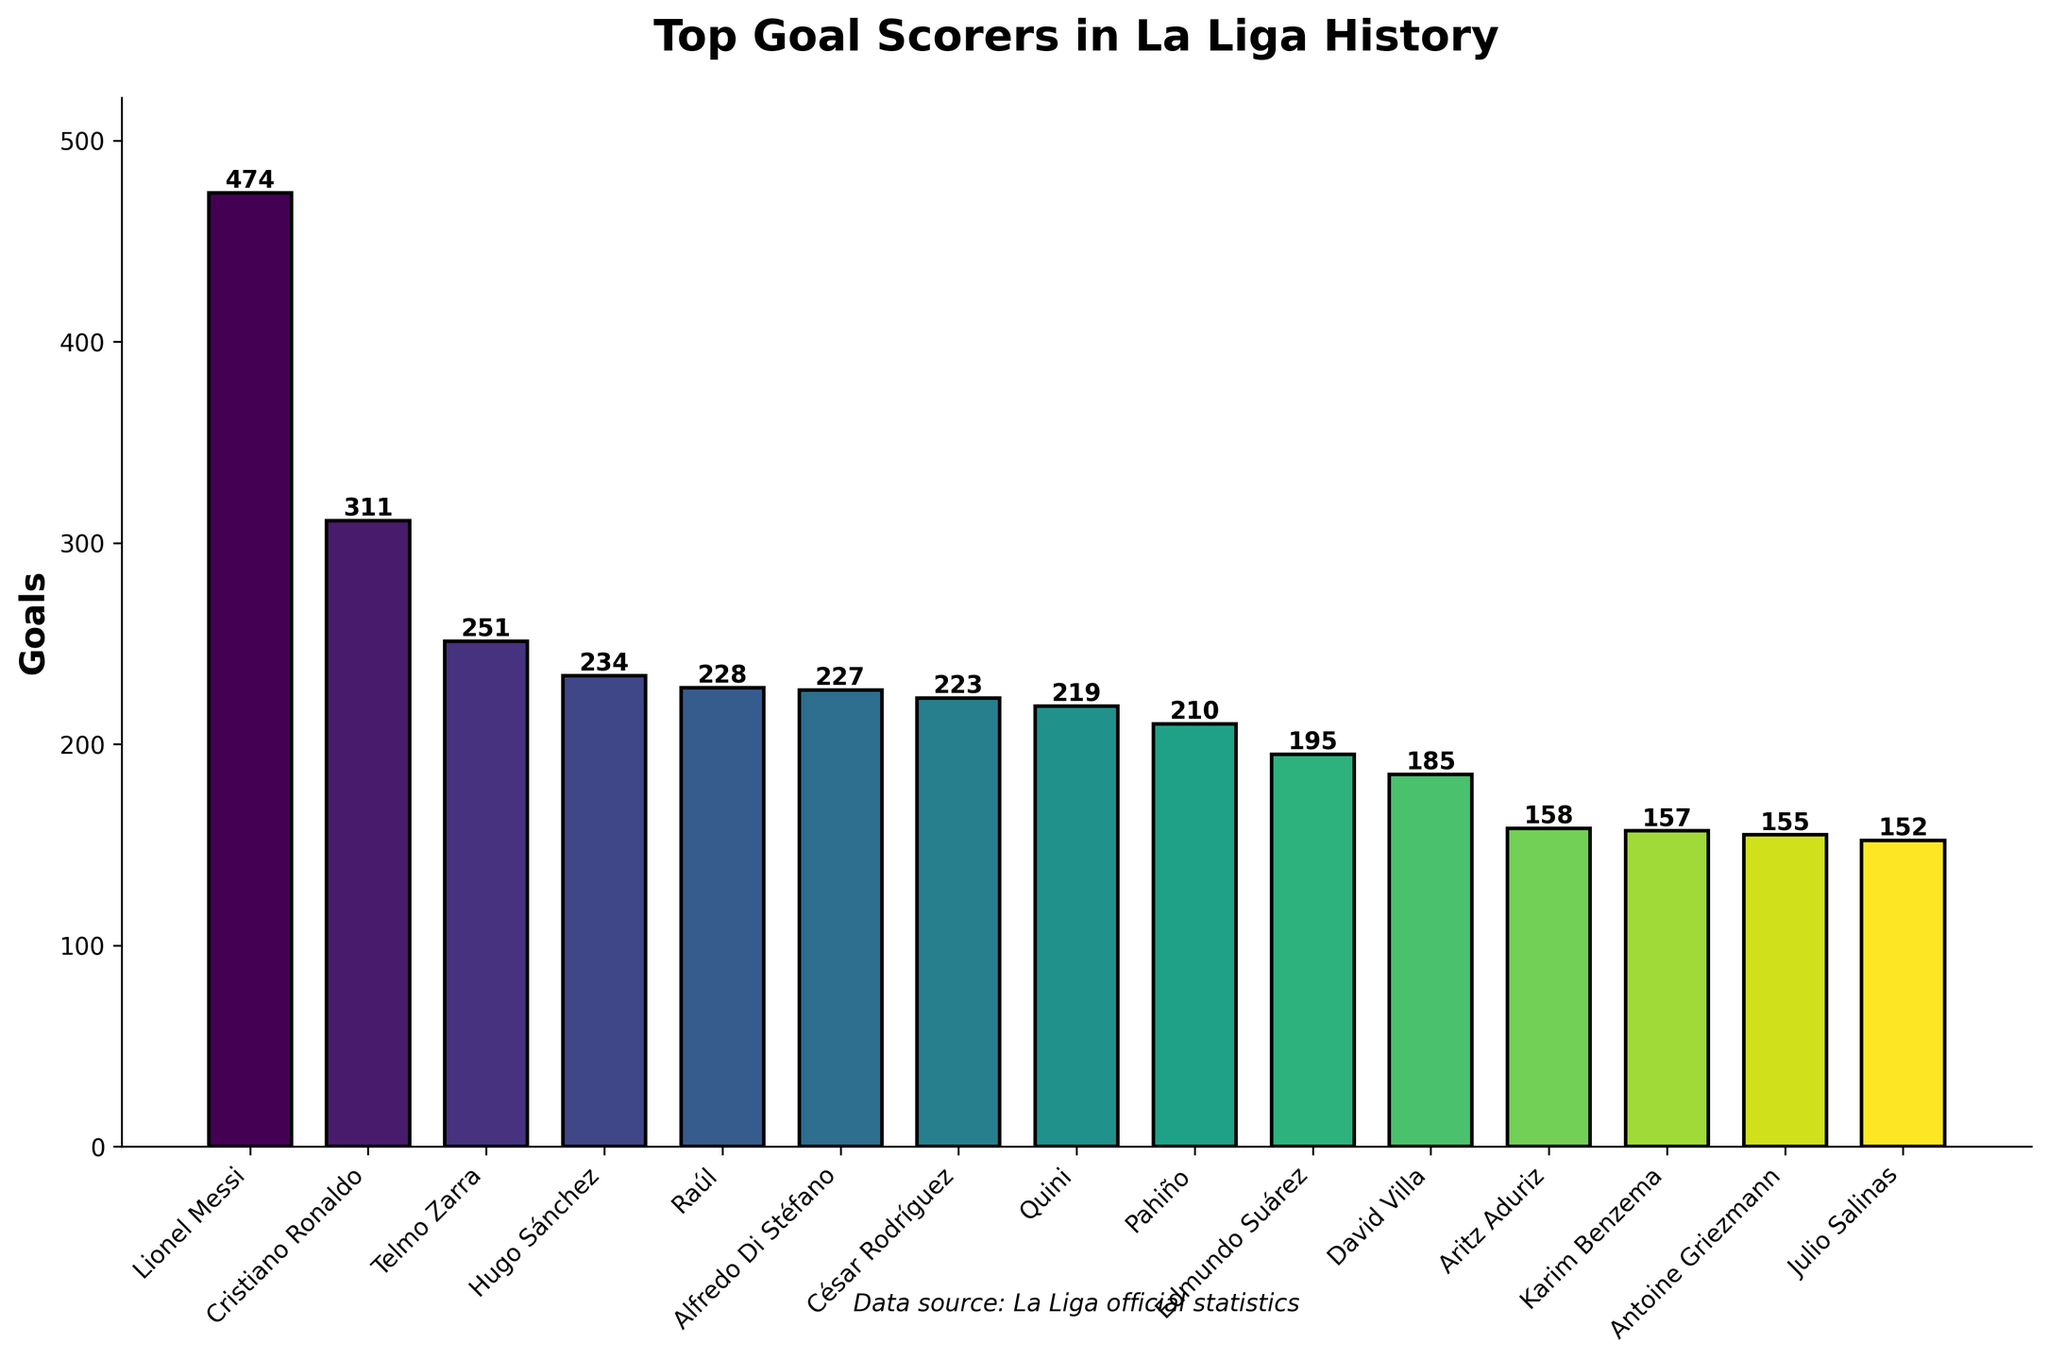What's the difference in goals between Lionel Messi and Cristiano Ronaldo? Lionel Messi has 474 goals, and Cristiano Ronaldo has 311 goals. The difference can be calculated by subtracting Ronaldo's goals from Messi's goals: 474 - 311 = 163.
Answer: 163 Who has scored more goals, Raúl or Alfredo Di Stéfano? Raúl has 228 goals, while Alfredo Di Stéfano has 227 goals. To determine who has more, we simply compare the two values.
Answer: Raúl How many goals do the top three scorers combined have? The top three scorers are Lionel Messi (474), Cristiano Ronaldo (311), and Telmo Zarra (251). Adding their goals together: 474 + 311 + 251 = 1036.
Answer: 1036 Is the number of goals by Hugo Sánchez greater than that of Quini and Pahiño combined? Hugo Sánchez has 234 goals. Quini has 219 goals, and Pahiño has 210 goals. First, add Quini and Pahiño's goals: 219 + 210 = 429. Now, compare Sánchez's goals with the combined total: 234 < 429.
Answer: No What's the median number of goals for the listed players? To find the median, list all goal counts in order: 152, 155, 157, 158, 185, 195, 210, 219, 223, 227, 228, 234, 251, 311, 474. The median is the middle value, here the 8th value in the ordered list: 219.
Answer: 219 Which player sits exactly in the middle when you arrange the players by the number of goals? Arranging by goals: 152, 155, 157, 158, 185, 195, 210, 219, 223, 227, 228, 234, 251, 311, 474. The player in the middle (8th position) is Quini.
Answer: Quini How many players have scored fewer than 200 goals? The players with fewer than 200 goals are: Aritz Aduriz (158), Karim Benzema (157), Antoine Griezmann (155), Julio Salinas (152), and David Villa (185). Count these players: 5.
Answer: 5 Which player scored the least goals among the top 10 scorers? The top 10 scorers based on the goals data are: Lionel Messi (474), Cristiano Ronaldo (311), Telmo Zarra (251), Hugo Sánchez (234), Raúl (228), Alfredo Di Stéfano (227), César Rodríguez (223), Quini (219), Pahiño (210), Edmundo Suárez (195). The player with the least is Edmundo Suárez with 195 goals.
Answer: Edmundo Suárez What colors are used for the bars that represent the highest and the lowest goal scorers? The highest goal scorer, Lionel Messi, is represented by the darkest shade of green in the viridis color map, while the lowest among the top 10, Edmundo Suárez, has a color from the lighter end of the same palette.
Answer: Dark green and light green 